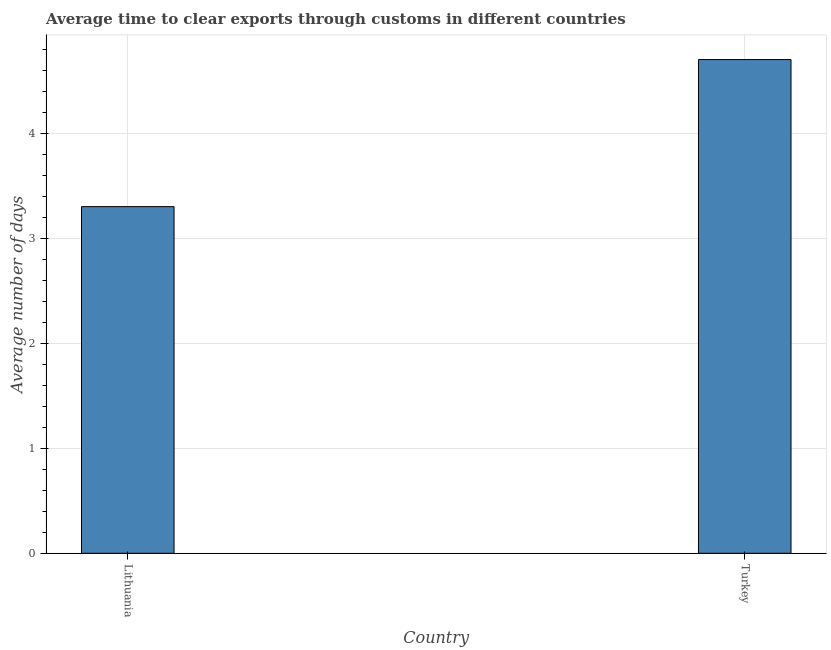Does the graph contain any zero values?
Your answer should be compact. No. Does the graph contain grids?
Keep it short and to the point. Yes. What is the title of the graph?
Ensure brevity in your answer.  Average time to clear exports through customs in different countries. What is the label or title of the X-axis?
Provide a short and direct response. Country. What is the label or title of the Y-axis?
Your response must be concise. Average number of days. Across all countries, what is the minimum time to clear exports through customs?
Your response must be concise. 3.3. In which country was the time to clear exports through customs maximum?
Offer a very short reply. Turkey. In which country was the time to clear exports through customs minimum?
Ensure brevity in your answer.  Lithuania. What is the difference between the time to clear exports through customs in Lithuania and Turkey?
Offer a very short reply. -1.4. What is the average time to clear exports through customs per country?
Your answer should be very brief. 4. What is the ratio of the time to clear exports through customs in Lithuania to that in Turkey?
Provide a succinct answer. 0.7. How many bars are there?
Provide a succinct answer. 2. Are all the bars in the graph horizontal?
Your answer should be very brief. No. How many countries are there in the graph?
Your answer should be compact. 2. What is the difference between two consecutive major ticks on the Y-axis?
Your response must be concise. 1. Are the values on the major ticks of Y-axis written in scientific E-notation?
Keep it short and to the point. No. What is the Average number of days of Turkey?
Your answer should be very brief. 4.7. What is the difference between the Average number of days in Lithuania and Turkey?
Offer a very short reply. -1.4. What is the ratio of the Average number of days in Lithuania to that in Turkey?
Your answer should be very brief. 0.7. 